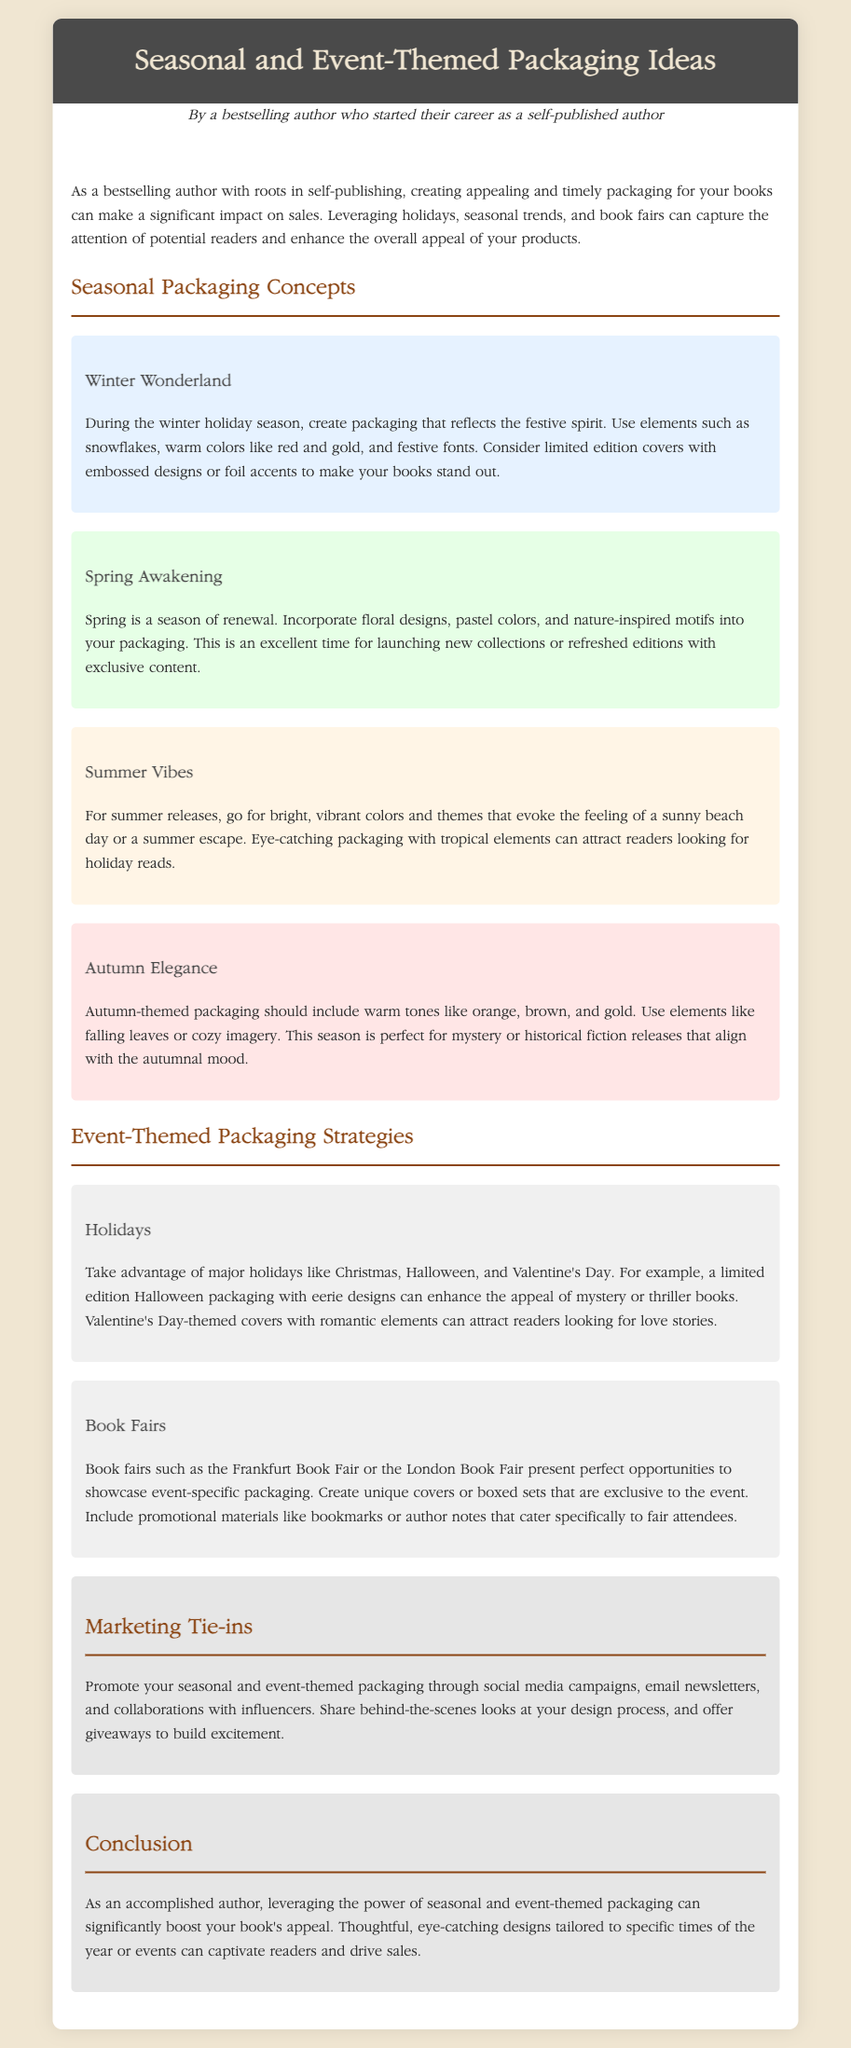What is the title of the document? The title of the document is stated in the header section.
Answer: Seasonal and Event-Themed Packaging Ideas Who is the author of the document? The author is mentioned in the author bio section.
Answer: A bestselling author who started their career as a self-published author What season is associated with floral designs in packaging? The content mentions spring as the season for floral designs.
Answer: Spring Which holiday is suggested for limited edition packaging with eerie designs? The document specifies Halloween for eerie designs.
Answer: Halloween What color scheme is suggested for autumn-themed packaging? The document describes warm tones like orange, brown, and gold for autumn.
Answer: Orange, brown, and gold What marketing strategy is recommended to promote seasonal packaging? The document mentions social media campaigns as a marketing strategy.
Answer: Social media campaigns During which event can unique covers and boxed sets be showcased? The text specifies book fairs as events for unique packaging.
Answer: Book fairs What are the suggested colors for summer packaging? The document notes bright, vibrant colors for summer packaging.
Answer: Bright, vibrant colors What type of content can be included with book fair packaging? The document states that promotional materials can be included.
Answer: Promotional materials 